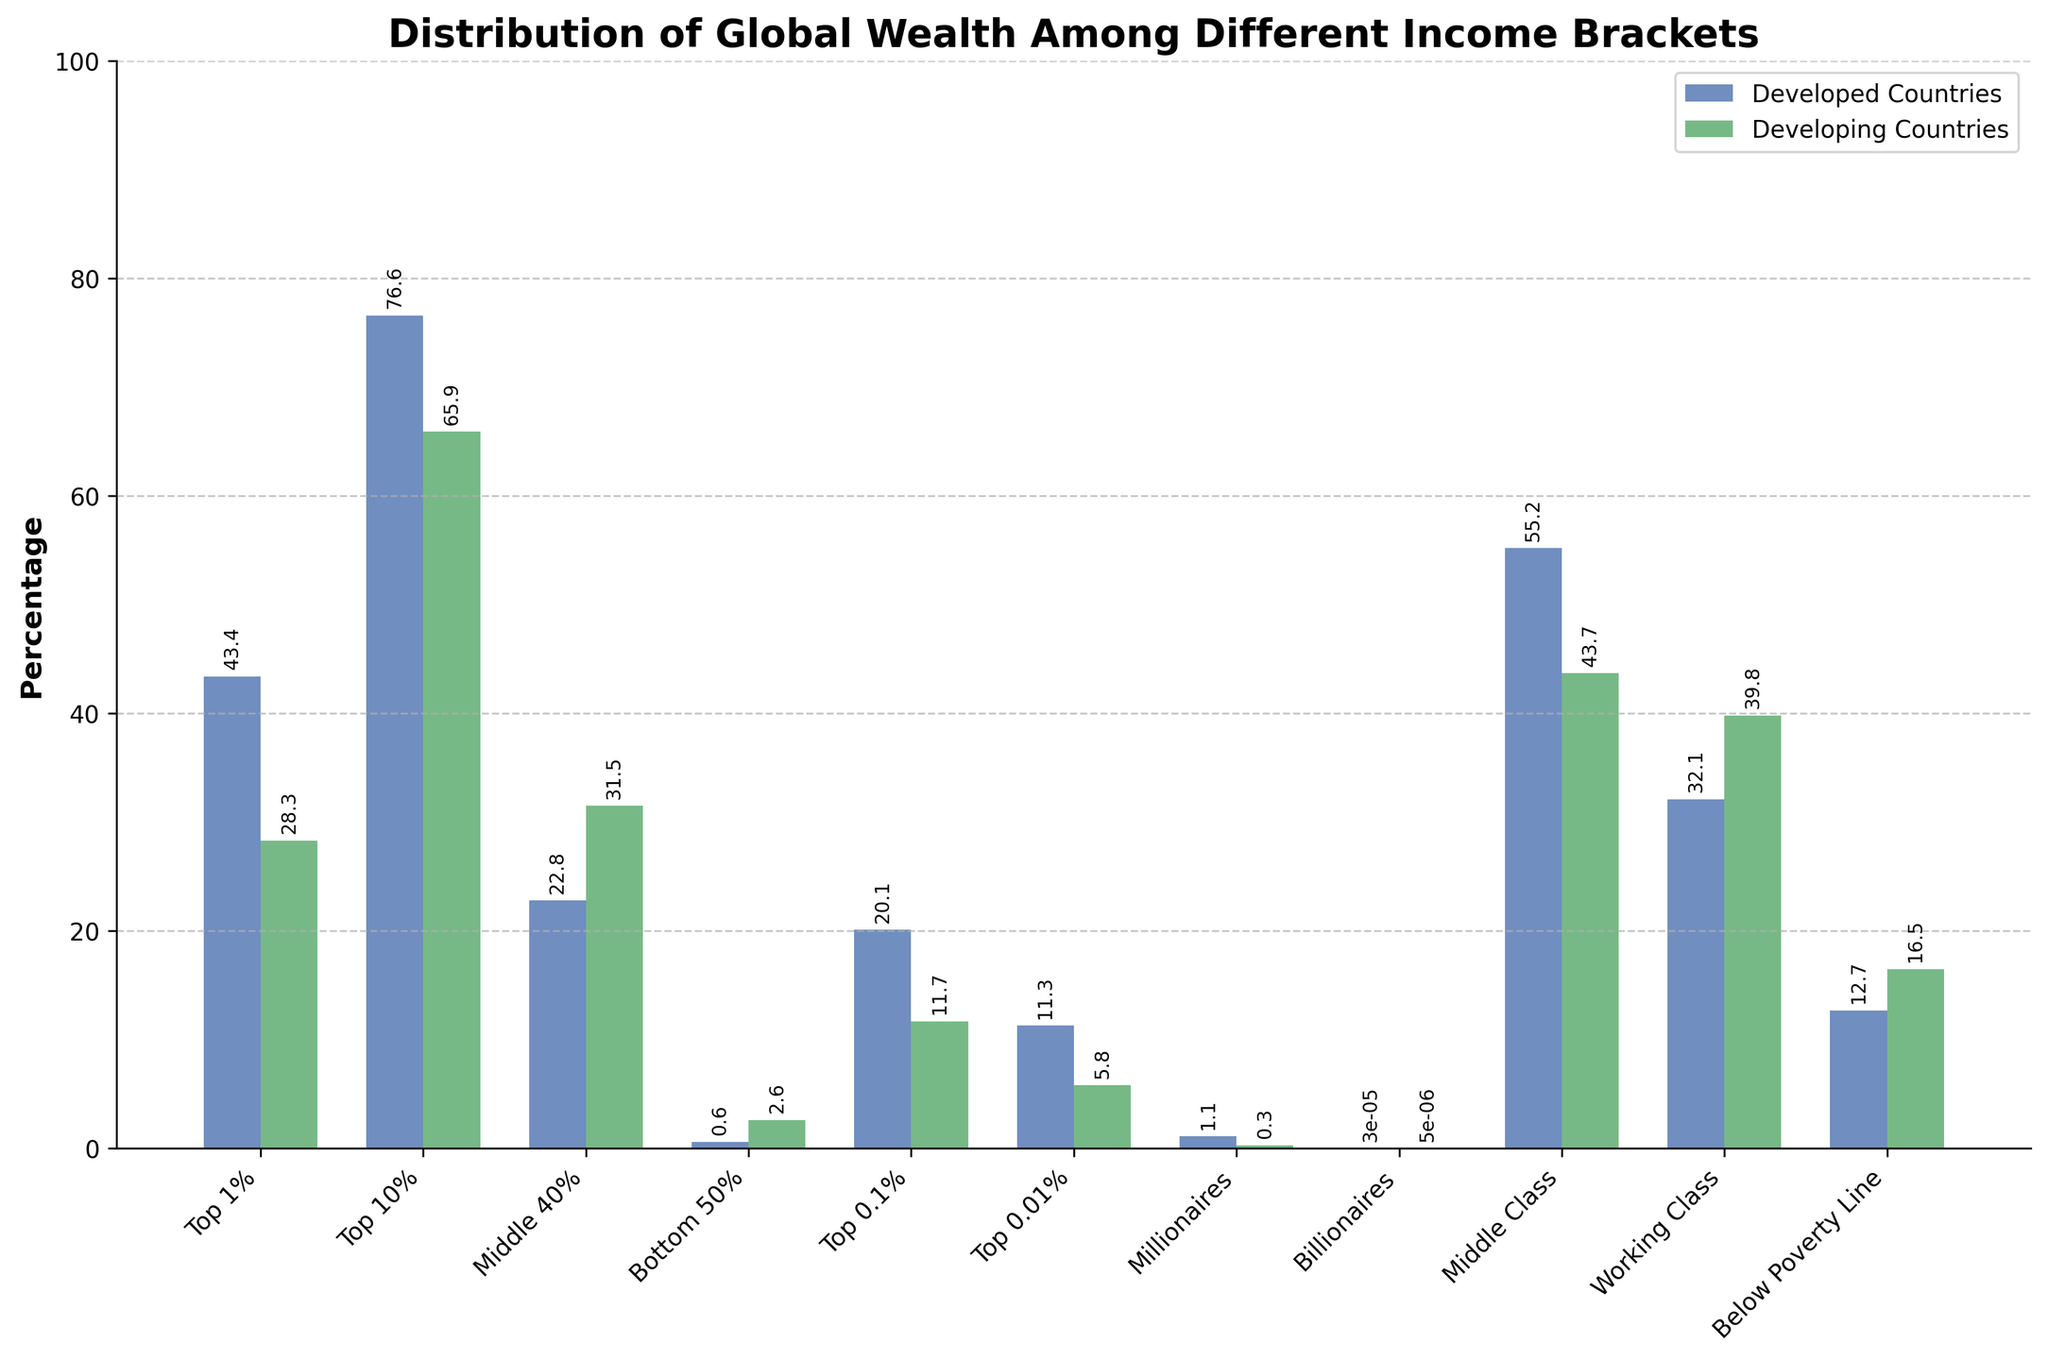What is the percentage of global wealth held by the Top 1% in developed countries compared to developing countries? To answer this, we look at the bar corresponding to the 'Top 1%' income bracket. In developed countries, the bar reaches 43.4%, while in developing countries, it reaches 28.3%.
Answer: Developed: 43.4%, Developing: 28.3% Which income bracket in developing countries has the highest percentage of global wealth? To answer this, observe the heights of the green bars in the plot for developing countries. The 'Top 10%' income bracket has the highest bar, indicating the highest percentage of global wealth, which is 65.9%.
Answer: Top 10% By how much does the percentage of global wealth held by the Middle Class differ between developed and developing countries? Subtract the percentage of the Middle Class in developing countries (43.7%) from the percentage in developed countries (55.2%) to find the difference: 55.2% - 43.7% = 11.5%.
Answer: 11.5% Which income bracket occupies a greater percentage of global wealth in developing countries compared to developed countries? Compare the heights of the bars for each income bracket. The 'Middle 40%' and 'Bottom 50%' bars are taller for developing countries than for developed countries.
Answer: Middle 40% and Bottom 50% What is the total percentage of global wealth held by the Top 0.1% and Top 0.01% in developed countries? Add the percentages of the Top 0.1% (20.1%) and Top 0.01% (11.3%) in developed countries: 20.1% + 11.3% = 31.4%.
Answer: 31.4% How does the percentage of wealth held by billionaires compare between developed and developing countries? Refer to the bars representing billionaires. In developed countries, it is 0.00003%, while in developing countries, it is 0.000005%. Since 0.00003% is greater than 0.000005%, billionaires hold more wealth in developed countries.
Answer: Developed: 0.00003%, Developing: 0.000005% Which class, 'Middle Class' or 'Working Class', holds a greater percentage of wealth in developed countries? Compare the bars for 'Middle Class' (55.2%) and 'Working Class' (32.1%) in developed countries. The 'Middle Class' bar is higher, indicating a greater percentage of wealth.
Answer: Middle Class What is the difference in percentage of wealth held by the 'Below Poverty Line' bracket between developed and developing countries? Subtract the percentage in developed countries (12.7%) from that in developing countries (16.5%): 16.5% - 12.7% = 3.8%.
Answer: 3.8% What percentage of global wealth is held by the Top 10% in developed countries? Look at the bar corresponding to the 'Top 10%' income bracket in developed countries. It shows 76.6%.
Answer: 76.6% Which income bracket has the smallest difference in the percentage of wealth between developed and developing countries, and what is the difference? Compare the differences for each income bracket. 'Billionaires' have the smallest absolute difference: 0.00003% - 0.000005% = 0.000025%.
Answer: Billionaires, 0.000025% 